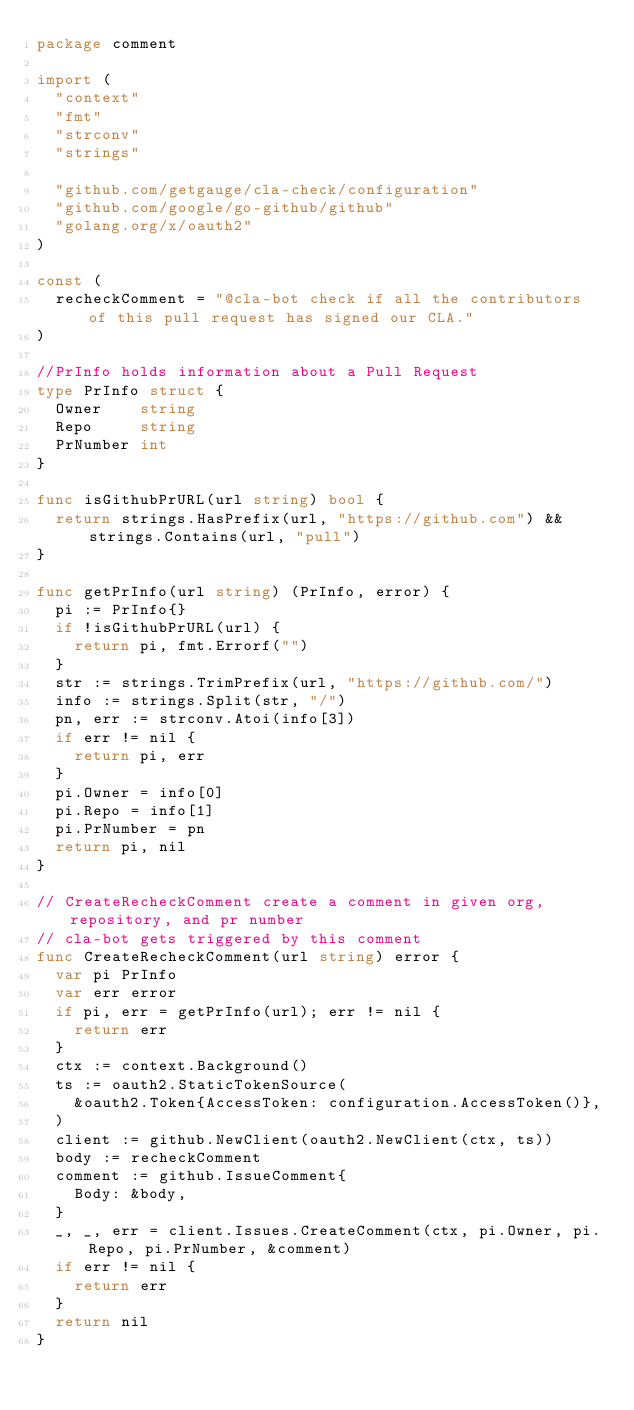<code> <loc_0><loc_0><loc_500><loc_500><_Go_>package comment

import (
	"context"
	"fmt"
	"strconv"
	"strings"

	"github.com/getgauge/cla-check/configuration"
	"github.com/google/go-github/github"
	"golang.org/x/oauth2"
)

const (
	recheckComment = "@cla-bot check if all the contributors of this pull request has signed our CLA."
)

//PrInfo holds information about a Pull Request
type PrInfo struct {
	Owner    string
	Repo     string
	PrNumber int
}

func isGithubPrURL(url string) bool {
	return strings.HasPrefix(url, "https://github.com") && strings.Contains(url, "pull")
}

func getPrInfo(url string) (PrInfo, error) {
	pi := PrInfo{}
	if !isGithubPrURL(url) {
		return pi, fmt.Errorf("")
	}
	str := strings.TrimPrefix(url, "https://github.com/")
	info := strings.Split(str, "/")
	pn, err := strconv.Atoi(info[3])
	if err != nil {
		return pi, err
	}
	pi.Owner = info[0]
	pi.Repo = info[1]
	pi.PrNumber = pn
	return pi, nil
}

// CreateRecheckComment create a comment in given org, repository, and pr number
// cla-bot gets triggered by this comment
func CreateRecheckComment(url string) error {
	var pi PrInfo
	var err error
	if pi, err = getPrInfo(url); err != nil {
		return err
	}
	ctx := context.Background()
	ts := oauth2.StaticTokenSource(
		&oauth2.Token{AccessToken: configuration.AccessToken()},
	)
	client := github.NewClient(oauth2.NewClient(ctx, ts))
	body := recheckComment
	comment := github.IssueComment{
		Body: &body,
	}
	_, _, err = client.Issues.CreateComment(ctx, pi.Owner, pi.Repo, pi.PrNumber, &comment)
	if err != nil {
		return err
	}
	return nil
}
</code> 